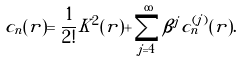Convert formula to latex. <formula><loc_0><loc_0><loc_500><loc_500>c _ { n } ( r ) = \frac { 1 } { 2 ! } K ^ { 2 } ( r ) + \sum _ { j = 4 } ^ { \infty } \beta ^ { j } c _ { n } ^ { ( j ) } ( r ) .</formula> 